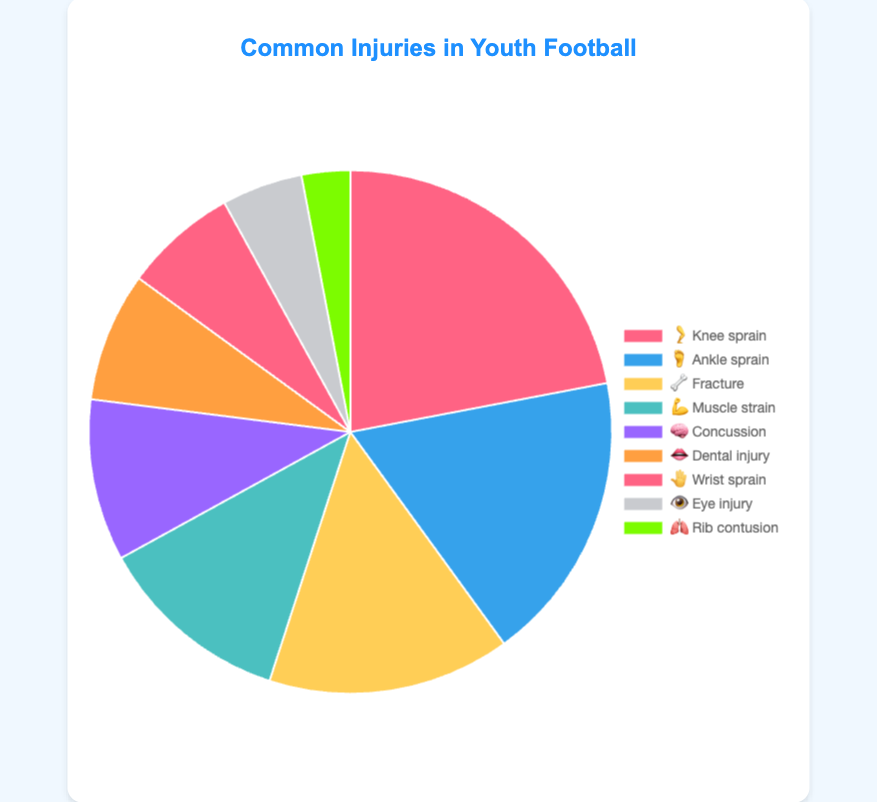what is the most common injury? The most common injury can be found by identifying the body part emoji and associated label with the highest percentage. The highest percentage is 22%, labeled 🦵 Knee sprain.
Answer: 🦵 Knee sprain What percentage of injuries are ankle sprain and muscle strain combined? Identify the percentages for ankle sprain (18%) and muscle strain (12%). Add them together: 18% + 12% = 30%.
Answer: 30% Which injury is more common, wrist sprain or dental injury? Compare the percentages for wrist sprain (7%) and dental injury (8%). Dental injury has a higher percentage than wrist sprain.
Answer: Dental injury How many injuries have percentages greater than 10%? Count the injuries with percentages higher than 10%. They are Knee sprain (22%), Ankle sprain (18%), Fracture (15%), and Muscle strain (12%). There are 4 injuries.
Answer: 4 What is the combined percentage of eye and rib injuries? Identify the percentages for eye injury (5%) and rib contusion (3%). Add them together: 5% + 3% = 8%.
Answer: 8% Which injury is less common, concussion or muscle strain? Compare the percentages for concussion (10%) and muscle strain (12%). Concussion has a lower percentage than muscle strain.
Answer: Concussion What is the total percentage of all injuries represented? Sum all the percentages given: 22% + 18% + 15% + 12% + 10% + 8% + 7% + 5% + 3% = 100%.
Answer: 100% What's the difference in percentage between the most common injury and the least common injury? The most common injury is Knee sprain (22%), and the least common injury is Rib contusion (3%). The difference is 22% - 3% = 19%.
Answer: 19% Which body part emoji represents the third most common injury? The percentages in descending order are 22%, 18%, and 15%. The third most common injury is Fracture, represented by the emoji 🦴.
Answer: 🦴 Fracture 